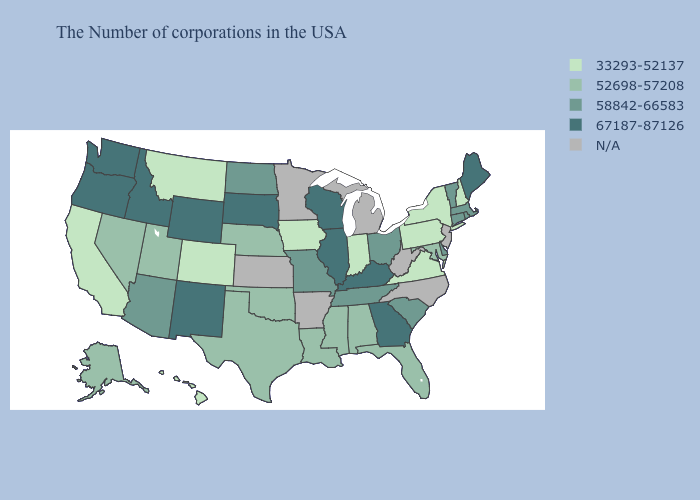What is the value of Michigan?
Keep it brief. N/A. Among the states that border Massachusetts , does New York have the highest value?
Keep it brief. No. Name the states that have a value in the range 33293-52137?
Concise answer only. New Hampshire, New York, Pennsylvania, Virginia, Indiana, Iowa, Colorado, Montana, California, Hawaii. What is the value of Washington?
Short answer required. 67187-87126. Name the states that have a value in the range N/A?
Keep it brief. New Jersey, North Carolina, West Virginia, Michigan, Arkansas, Minnesota, Kansas. Does Colorado have the lowest value in the USA?
Write a very short answer. Yes. What is the value of Indiana?
Short answer required. 33293-52137. Which states have the lowest value in the USA?
Keep it brief. New Hampshire, New York, Pennsylvania, Virginia, Indiana, Iowa, Colorado, Montana, California, Hawaii. Name the states that have a value in the range 58842-66583?
Write a very short answer. Massachusetts, Rhode Island, Vermont, Connecticut, Delaware, South Carolina, Ohio, Tennessee, Missouri, North Dakota, Arizona. Name the states that have a value in the range 52698-57208?
Answer briefly. Maryland, Florida, Alabama, Mississippi, Louisiana, Nebraska, Oklahoma, Texas, Utah, Nevada, Alaska. What is the lowest value in the South?
Concise answer only. 33293-52137. Among the states that border New Jersey , which have the highest value?
Be succinct. Delaware. What is the lowest value in the USA?
Be succinct. 33293-52137. Which states have the lowest value in the South?
Give a very brief answer. Virginia. 